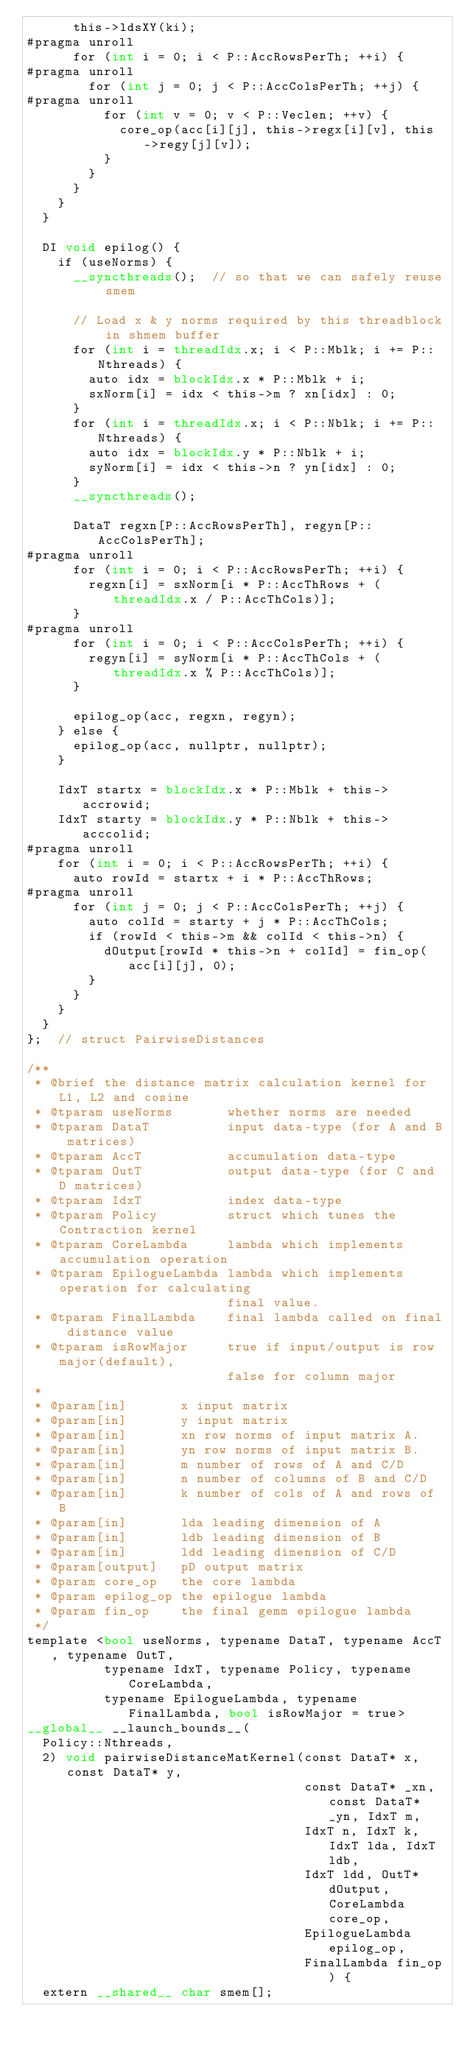Convert code to text. <code><loc_0><loc_0><loc_500><loc_500><_Cuda_>      this->ldsXY(ki);
#pragma unroll
      for (int i = 0; i < P::AccRowsPerTh; ++i) {
#pragma unroll
        for (int j = 0; j < P::AccColsPerTh; ++j) {
#pragma unroll
          for (int v = 0; v < P::Veclen; ++v) {
            core_op(acc[i][j], this->regx[i][v], this->regy[j][v]);
          }
        }
      }
    }
  }

  DI void epilog() {
    if (useNorms) {
      __syncthreads();  // so that we can safely reuse smem

      // Load x & y norms required by this threadblock in shmem buffer
      for (int i = threadIdx.x; i < P::Mblk; i += P::Nthreads) {
        auto idx = blockIdx.x * P::Mblk + i;
        sxNorm[i] = idx < this->m ? xn[idx] : 0;
      }
      for (int i = threadIdx.x; i < P::Nblk; i += P::Nthreads) {
        auto idx = blockIdx.y * P::Nblk + i;
        syNorm[i] = idx < this->n ? yn[idx] : 0;
      }
      __syncthreads();

      DataT regxn[P::AccRowsPerTh], regyn[P::AccColsPerTh];
#pragma unroll
      for (int i = 0; i < P::AccRowsPerTh; ++i) {
        regxn[i] = sxNorm[i * P::AccThRows + (threadIdx.x / P::AccThCols)];
      }
#pragma unroll
      for (int i = 0; i < P::AccColsPerTh; ++i) {
        regyn[i] = syNorm[i * P::AccThCols + (threadIdx.x % P::AccThCols)];
      }

      epilog_op(acc, regxn, regyn);
    } else {
      epilog_op(acc, nullptr, nullptr);
    }

    IdxT startx = blockIdx.x * P::Mblk + this->accrowid;
    IdxT starty = blockIdx.y * P::Nblk + this->acccolid;
#pragma unroll
    for (int i = 0; i < P::AccRowsPerTh; ++i) {
      auto rowId = startx + i * P::AccThRows;
#pragma unroll
      for (int j = 0; j < P::AccColsPerTh; ++j) {
        auto colId = starty + j * P::AccThCols;
        if (rowId < this->m && colId < this->n) {
          dOutput[rowId * this->n + colId] = fin_op(acc[i][j], 0);
        }
      }
    }
  }
};  // struct PairwiseDistances

/**
 * @brief the distance matrix calculation kernel for L1, L2 and cosine
 * @tparam useNorms       whether norms are needed
 * @tparam DataT          input data-type (for A and B matrices)
 * @tparam AccT           accumulation data-type
 * @tparam OutT           output data-type (for C and D matrices)
 * @tparam IdxT           index data-type
 * @tparam Policy         struct which tunes the Contraction kernel
 * @tparam CoreLambda     lambda which implements accumulation operation
 * @tparam EpilogueLambda lambda which implements operation for calculating
                          final value.
 * @tparam FinalLambda    final lambda called on final distance value
 * @tparam isRowMajor     true if input/output is row major(default),
                          false for column major
 *
 * @param[in]       x input matrix
 * @param[in]       y input matrix
 * @param[in]       xn row norms of input matrix A.
 * @param[in]       yn row norms of input matrix B.
 * @param[in]       m number of rows of A and C/D
 * @param[in]       n number of columns of B and C/D
 * @param[in]       k number of cols of A and rows of B
 * @param[in]       lda leading dimension of A
 * @param[in]       ldb leading dimension of B
 * @param[in]       ldd leading dimension of C/D
 * @param[output]   pD output matrix
 * @param core_op   the core lambda
 * @param epilog_op the epilogue lambda
 * @param fin_op    the final gemm epilogue lambda
 */
template <bool useNorms, typename DataT, typename AccT, typename OutT,
          typename IdxT, typename Policy, typename CoreLambda,
          typename EpilogueLambda, typename FinalLambda, bool isRowMajor = true>
__global__ __launch_bounds__(
  Policy::Nthreads,
  2) void pairwiseDistanceMatKernel(const DataT* x, const DataT* y,
                                    const DataT* _xn, const DataT* _yn, IdxT m,
                                    IdxT n, IdxT k, IdxT lda, IdxT ldb,
                                    IdxT ldd, OutT* dOutput, CoreLambda core_op,
                                    EpilogueLambda epilog_op,
                                    FinalLambda fin_op) {
  extern __shared__ char smem[];
</code> 